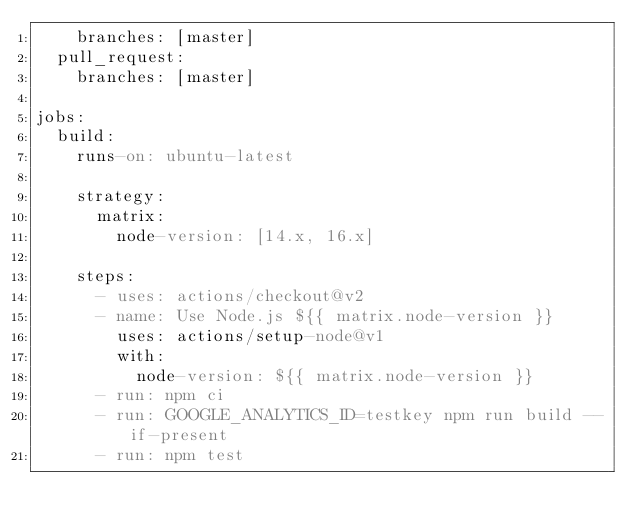<code> <loc_0><loc_0><loc_500><loc_500><_YAML_>    branches: [master]
  pull_request:
    branches: [master]

jobs:
  build:
    runs-on: ubuntu-latest

    strategy:
      matrix:
        node-version: [14.x, 16.x]

    steps:
      - uses: actions/checkout@v2
      - name: Use Node.js ${{ matrix.node-version }}
        uses: actions/setup-node@v1
        with:
          node-version: ${{ matrix.node-version }}
      - run: npm ci
      - run: GOOGLE_ANALYTICS_ID=testkey npm run build --if-present
      - run: npm test
</code> 